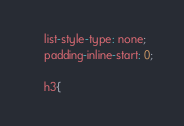Convert code to text. <code><loc_0><loc_0><loc_500><loc_500><_JavaScript_>
    list-style-type: none;
    padding-inline-start: 0;

    h3{</code> 